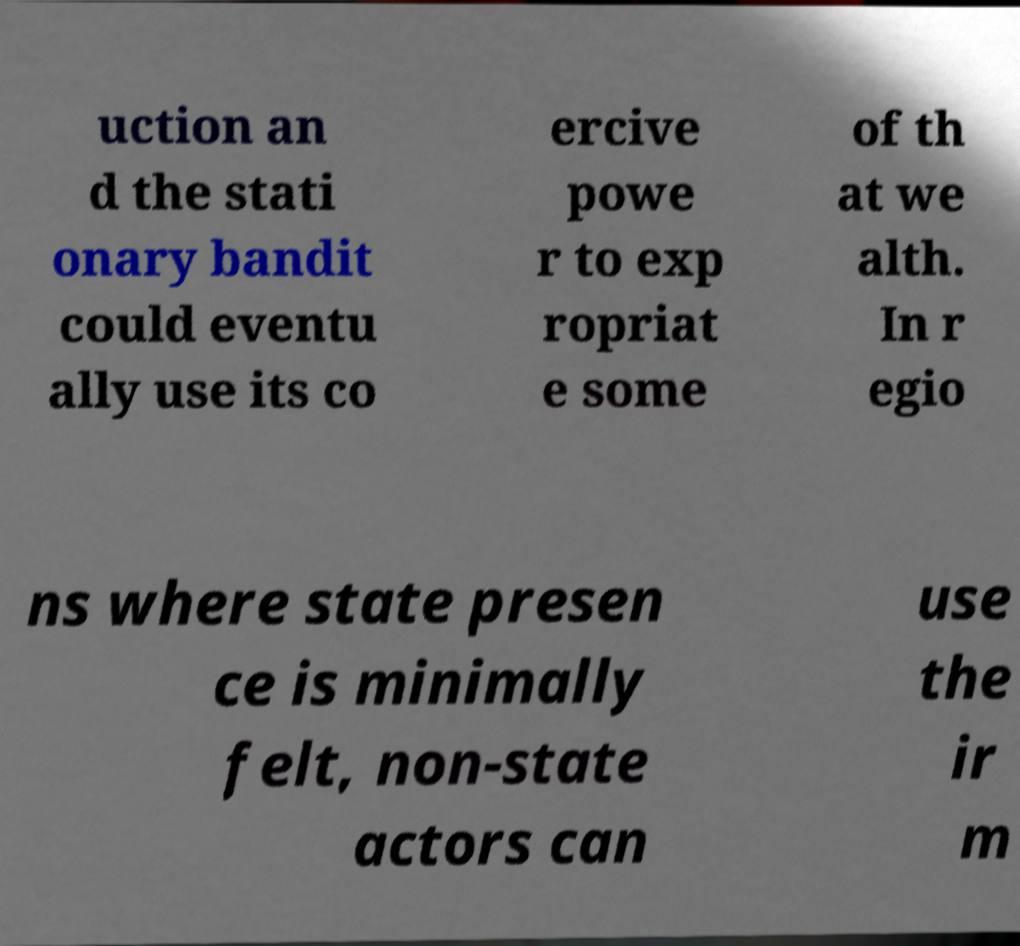Please read and relay the text visible in this image. What does it say? uction an d the stati onary bandit could eventu ally use its co ercive powe r to exp ropriat e some of th at we alth. In r egio ns where state presen ce is minimally felt, non-state actors can use the ir m 